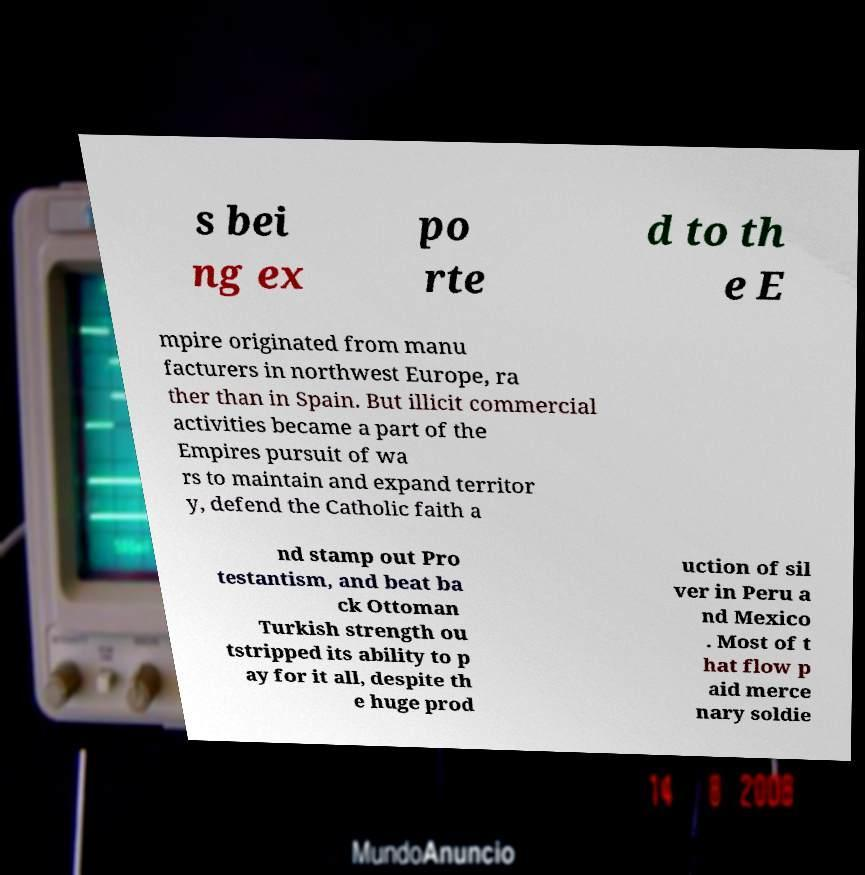Can you accurately transcribe the text from the provided image for me? s bei ng ex po rte d to th e E mpire originated from manu facturers in northwest Europe, ra ther than in Spain. But illicit commercial activities became a part of the Empires pursuit of wa rs to maintain and expand territor y, defend the Catholic faith a nd stamp out Pro testantism, and beat ba ck Ottoman Turkish strength ou tstripped its ability to p ay for it all, despite th e huge prod uction of sil ver in Peru a nd Mexico . Most of t hat flow p aid merce nary soldie 